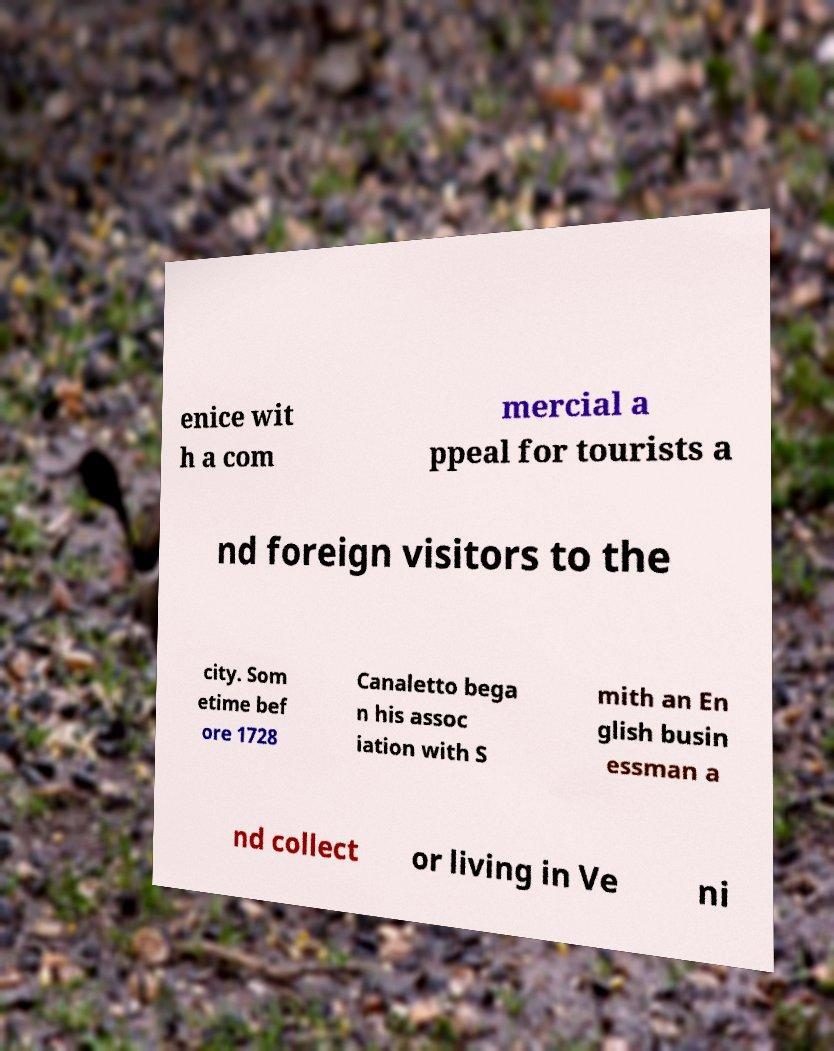I need the written content from this picture converted into text. Can you do that? enice wit h a com mercial a ppeal for tourists a nd foreign visitors to the city. Som etime bef ore 1728 Canaletto bega n his assoc iation with S mith an En glish busin essman a nd collect or living in Ve ni 